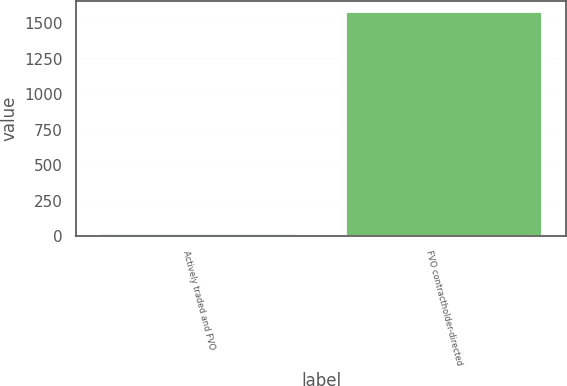Convert chart. <chart><loc_0><loc_0><loc_500><loc_500><bar_chart><fcel>Actively traded and FVO<fcel>FVO contractholder-directed<nl><fcel>18<fcel>1579<nl></chart> 